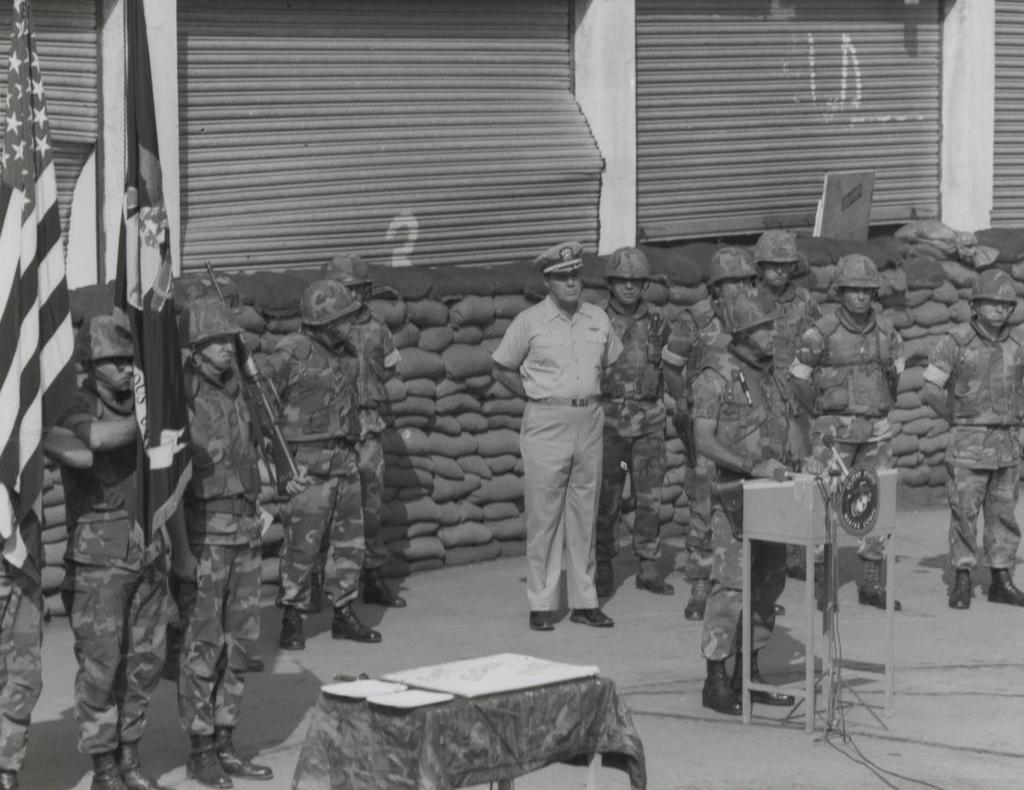How would you summarize this image in a sentence or two? In this picture there is a flag. To the left side, there are four people who are standing. There is a shutter. To the right side, there are group of people and they are also standing. There is a mic. At background, there are some bags. In the middle, there is a man who is wearing a cap and is standing. 